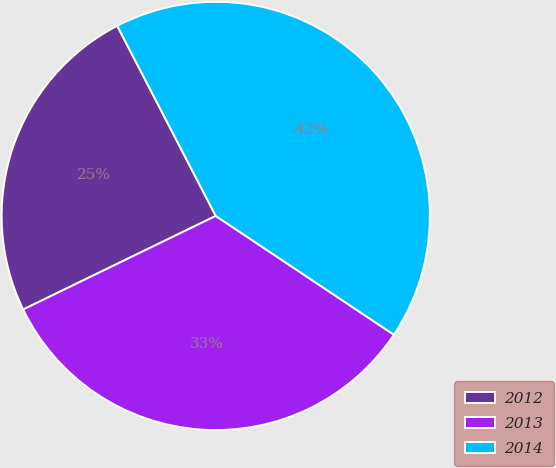Convert chart to OTSL. <chart><loc_0><loc_0><loc_500><loc_500><pie_chart><fcel>2012<fcel>2013<fcel>2014<nl><fcel>24.59%<fcel>33.44%<fcel>41.97%<nl></chart> 